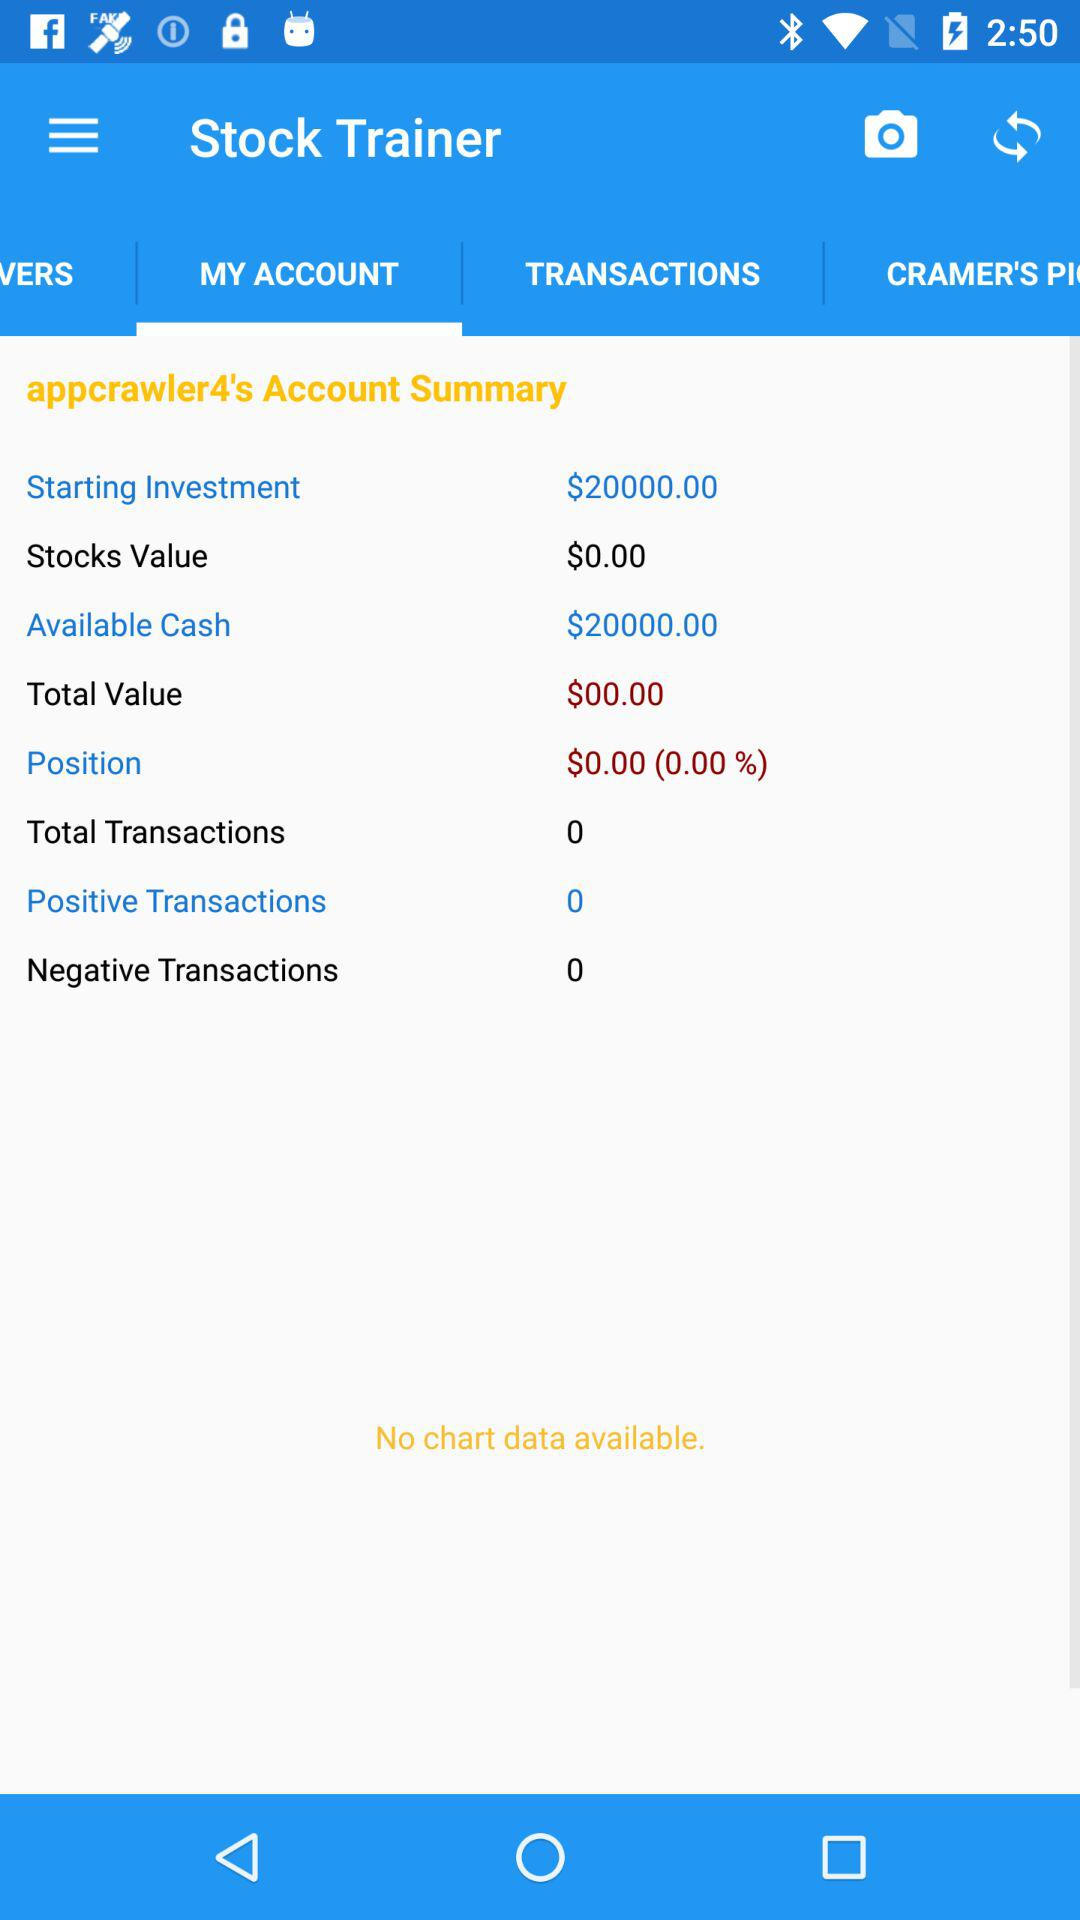How much more money is available cash than stocks value?
Answer the question using a single word or phrase. $20000.00 